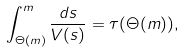<formula> <loc_0><loc_0><loc_500><loc_500>\int _ { \Theta ( m ) } ^ { m } \frac { d s } { V ( s ) } = \tau ( \Theta ( m ) ) ,</formula> 